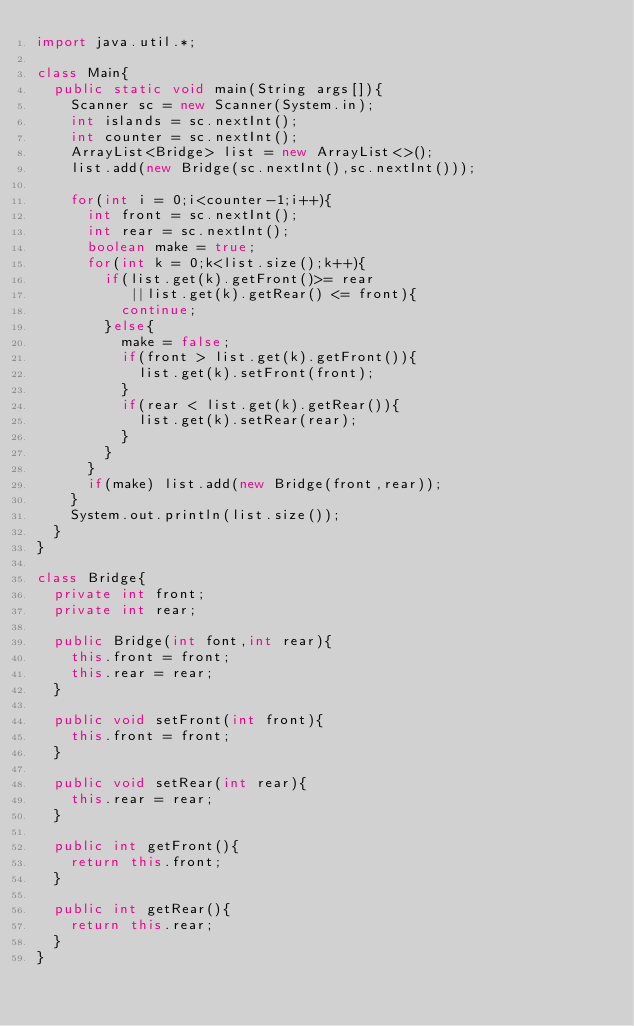<code> <loc_0><loc_0><loc_500><loc_500><_Java_>import java.util.*;

class Main{
  public static void main(String args[]){
    Scanner sc = new Scanner(System.in);
    int islands = sc.nextInt();
    int counter = sc.nextInt();
    ArrayList<Bridge> list = new ArrayList<>();
    list.add(new Bridge(sc.nextInt(),sc.nextInt()));
    
    for(int i = 0;i<counter-1;i++){
      int front = sc.nextInt();
      int rear = sc.nextInt();
      boolean make = true;
      for(int k = 0;k<list.size();k++){
        if(list.get(k).getFront()>= rear
           ||list.get(k).getRear() <= front){
          continue;
        }else{
          make = false;
          if(front > list.get(k).getFront()){
            list.get(k).setFront(front);
          }
          if(rear < list.get(k).getRear()){
            list.get(k).setRear(rear);
          }
        }
      }
      if(make) list.add(new Bridge(front,rear));
    }
    System.out.println(list.size());
  }
}

class Bridge{
  private int front;
  private int rear;
  
  public Bridge(int font,int rear){
    this.front = front;
    this.rear = rear;
  }
  
  public void setFront(int front){
    this.front = front;
  }
  
  public void setRear(int rear){
    this.rear = rear;
  }
  
  public int getFront(){
    return this.front;
  }
  
  public int getRear(){
    return this.rear;
  }
}</code> 